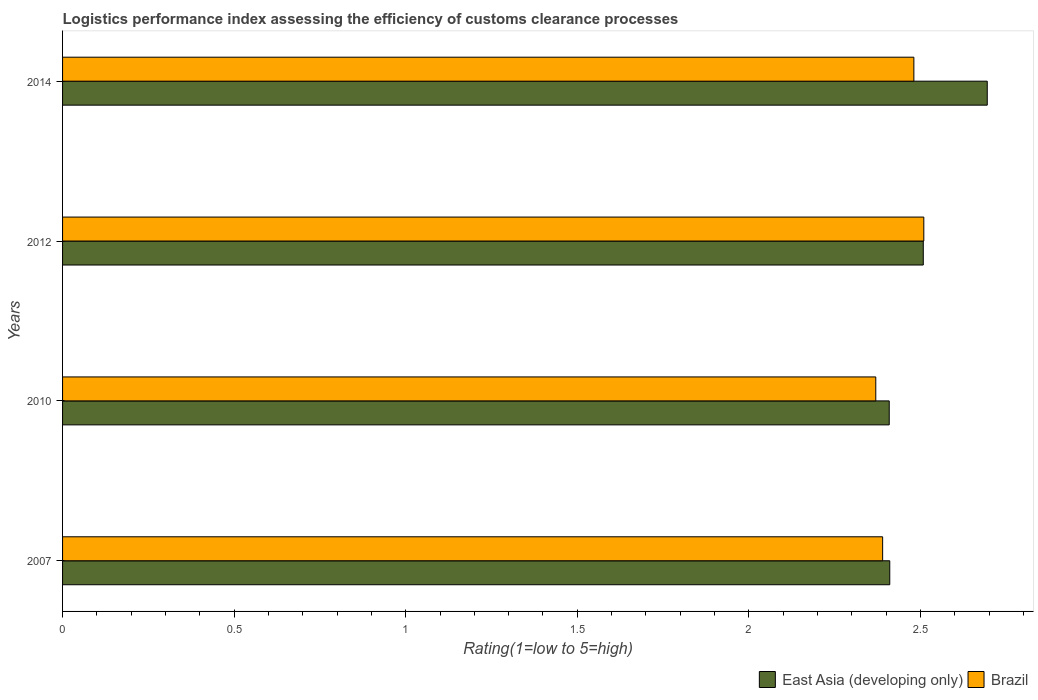How many groups of bars are there?
Give a very brief answer. 4. What is the Logistic performance index in East Asia (developing only) in 2012?
Offer a terse response. 2.51. Across all years, what is the maximum Logistic performance index in East Asia (developing only)?
Provide a succinct answer. 2.69. Across all years, what is the minimum Logistic performance index in East Asia (developing only)?
Your answer should be very brief. 2.41. In which year was the Logistic performance index in East Asia (developing only) minimum?
Offer a terse response. 2010. What is the total Logistic performance index in East Asia (developing only) in the graph?
Offer a very short reply. 10.02. What is the difference between the Logistic performance index in East Asia (developing only) in 2007 and that in 2010?
Provide a short and direct response. 0. What is the difference between the Logistic performance index in East Asia (developing only) in 2014 and the Logistic performance index in Brazil in 2012?
Make the answer very short. 0.18. What is the average Logistic performance index in East Asia (developing only) per year?
Ensure brevity in your answer.  2.51. In the year 2010, what is the difference between the Logistic performance index in East Asia (developing only) and Logistic performance index in Brazil?
Your response must be concise. 0.04. In how many years, is the Logistic performance index in East Asia (developing only) greater than 2 ?
Your response must be concise. 4. What is the ratio of the Logistic performance index in Brazil in 2007 to that in 2012?
Keep it short and to the point. 0.95. Is the Logistic performance index in Brazil in 2010 less than that in 2012?
Offer a terse response. Yes. Is the difference between the Logistic performance index in East Asia (developing only) in 2012 and 2014 greater than the difference between the Logistic performance index in Brazil in 2012 and 2014?
Make the answer very short. No. What is the difference between the highest and the second highest Logistic performance index in Brazil?
Ensure brevity in your answer.  0.03. What is the difference between the highest and the lowest Logistic performance index in East Asia (developing only)?
Give a very brief answer. 0.29. In how many years, is the Logistic performance index in East Asia (developing only) greater than the average Logistic performance index in East Asia (developing only) taken over all years?
Your answer should be compact. 2. What does the 2nd bar from the top in 2007 represents?
Your answer should be compact. East Asia (developing only). How many years are there in the graph?
Ensure brevity in your answer.  4. What is the difference between two consecutive major ticks on the X-axis?
Ensure brevity in your answer.  0.5. Does the graph contain any zero values?
Offer a very short reply. No. How many legend labels are there?
Offer a terse response. 2. How are the legend labels stacked?
Give a very brief answer. Horizontal. What is the title of the graph?
Provide a short and direct response. Logistics performance index assessing the efficiency of customs clearance processes. What is the label or title of the X-axis?
Provide a succinct answer. Rating(1=low to 5=high). What is the label or title of the Y-axis?
Your answer should be compact. Years. What is the Rating(1=low to 5=high) of East Asia (developing only) in 2007?
Your answer should be very brief. 2.41. What is the Rating(1=low to 5=high) in Brazil in 2007?
Ensure brevity in your answer.  2.39. What is the Rating(1=low to 5=high) in East Asia (developing only) in 2010?
Keep it short and to the point. 2.41. What is the Rating(1=low to 5=high) of Brazil in 2010?
Give a very brief answer. 2.37. What is the Rating(1=low to 5=high) of East Asia (developing only) in 2012?
Offer a very short reply. 2.51. What is the Rating(1=low to 5=high) in Brazil in 2012?
Make the answer very short. 2.51. What is the Rating(1=low to 5=high) in East Asia (developing only) in 2014?
Provide a succinct answer. 2.69. What is the Rating(1=low to 5=high) of Brazil in 2014?
Make the answer very short. 2.48. Across all years, what is the maximum Rating(1=low to 5=high) in East Asia (developing only)?
Ensure brevity in your answer.  2.69. Across all years, what is the maximum Rating(1=low to 5=high) in Brazil?
Your answer should be compact. 2.51. Across all years, what is the minimum Rating(1=low to 5=high) of East Asia (developing only)?
Give a very brief answer. 2.41. Across all years, what is the minimum Rating(1=low to 5=high) in Brazil?
Provide a succinct answer. 2.37. What is the total Rating(1=low to 5=high) of East Asia (developing only) in the graph?
Give a very brief answer. 10.02. What is the total Rating(1=low to 5=high) of Brazil in the graph?
Your answer should be very brief. 9.75. What is the difference between the Rating(1=low to 5=high) of East Asia (developing only) in 2007 and that in 2010?
Keep it short and to the point. 0. What is the difference between the Rating(1=low to 5=high) of East Asia (developing only) in 2007 and that in 2012?
Offer a terse response. -0.1. What is the difference between the Rating(1=low to 5=high) in Brazil in 2007 and that in 2012?
Make the answer very short. -0.12. What is the difference between the Rating(1=low to 5=high) of East Asia (developing only) in 2007 and that in 2014?
Your answer should be very brief. -0.28. What is the difference between the Rating(1=low to 5=high) of Brazil in 2007 and that in 2014?
Provide a succinct answer. -0.09. What is the difference between the Rating(1=low to 5=high) in East Asia (developing only) in 2010 and that in 2012?
Provide a short and direct response. -0.1. What is the difference between the Rating(1=low to 5=high) in Brazil in 2010 and that in 2012?
Your answer should be compact. -0.14. What is the difference between the Rating(1=low to 5=high) in East Asia (developing only) in 2010 and that in 2014?
Your response must be concise. -0.29. What is the difference between the Rating(1=low to 5=high) in Brazil in 2010 and that in 2014?
Ensure brevity in your answer.  -0.11. What is the difference between the Rating(1=low to 5=high) of East Asia (developing only) in 2012 and that in 2014?
Keep it short and to the point. -0.19. What is the difference between the Rating(1=low to 5=high) in Brazil in 2012 and that in 2014?
Make the answer very short. 0.03. What is the difference between the Rating(1=low to 5=high) in East Asia (developing only) in 2007 and the Rating(1=low to 5=high) in Brazil in 2010?
Keep it short and to the point. 0.04. What is the difference between the Rating(1=low to 5=high) in East Asia (developing only) in 2007 and the Rating(1=low to 5=high) in Brazil in 2012?
Offer a terse response. -0.1. What is the difference between the Rating(1=low to 5=high) in East Asia (developing only) in 2007 and the Rating(1=low to 5=high) in Brazil in 2014?
Provide a short and direct response. -0.07. What is the difference between the Rating(1=low to 5=high) in East Asia (developing only) in 2010 and the Rating(1=low to 5=high) in Brazil in 2012?
Offer a very short reply. -0.1. What is the difference between the Rating(1=low to 5=high) of East Asia (developing only) in 2010 and the Rating(1=low to 5=high) of Brazil in 2014?
Make the answer very short. -0.07. What is the difference between the Rating(1=low to 5=high) of East Asia (developing only) in 2012 and the Rating(1=low to 5=high) of Brazil in 2014?
Make the answer very short. 0.03. What is the average Rating(1=low to 5=high) in East Asia (developing only) per year?
Ensure brevity in your answer.  2.51. What is the average Rating(1=low to 5=high) in Brazil per year?
Provide a short and direct response. 2.44. In the year 2007, what is the difference between the Rating(1=low to 5=high) of East Asia (developing only) and Rating(1=low to 5=high) of Brazil?
Make the answer very short. 0.02. In the year 2010, what is the difference between the Rating(1=low to 5=high) in East Asia (developing only) and Rating(1=low to 5=high) in Brazil?
Offer a very short reply. 0.04. In the year 2012, what is the difference between the Rating(1=low to 5=high) in East Asia (developing only) and Rating(1=low to 5=high) in Brazil?
Offer a terse response. -0. In the year 2014, what is the difference between the Rating(1=low to 5=high) in East Asia (developing only) and Rating(1=low to 5=high) in Brazil?
Your answer should be very brief. 0.21. What is the ratio of the Rating(1=low to 5=high) in East Asia (developing only) in 2007 to that in 2010?
Provide a succinct answer. 1. What is the ratio of the Rating(1=low to 5=high) in Brazil in 2007 to that in 2010?
Your response must be concise. 1.01. What is the ratio of the Rating(1=low to 5=high) in East Asia (developing only) in 2007 to that in 2012?
Offer a very short reply. 0.96. What is the ratio of the Rating(1=low to 5=high) in Brazil in 2007 to that in 2012?
Give a very brief answer. 0.95. What is the ratio of the Rating(1=low to 5=high) in East Asia (developing only) in 2007 to that in 2014?
Provide a short and direct response. 0.89. What is the ratio of the Rating(1=low to 5=high) in Brazil in 2007 to that in 2014?
Ensure brevity in your answer.  0.96. What is the ratio of the Rating(1=low to 5=high) in East Asia (developing only) in 2010 to that in 2012?
Your response must be concise. 0.96. What is the ratio of the Rating(1=low to 5=high) in Brazil in 2010 to that in 2012?
Keep it short and to the point. 0.94. What is the ratio of the Rating(1=low to 5=high) in East Asia (developing only) in 2010 to that in 2014?
Your response must be concise. 0.89. What is the ratio of the Rating(1=low to 5=high) in Brazil in 2010 to that in 2014?
Your answer should be very brief. 0.96. What is the ratio of the Rating(1=low to 5=high) of East Asia (developing only) in 2012 to that in 2014?
Provide a short and direct response. 0.93. What is the ratio of the Rating(1=low to 5=high) of Brazil in 2012 to that in 2014?
Make the answer very short. 1.01. What is the difference between the highest and the second highest Rating(1=low to 5=high) of East Asia (developing only)?
Your response must be concise. 0.19. What is the difference between the highest and the second highest Rating(1=low to 5=high) of Brazil?
Offer a very short reply. 0.03. What is the difference between the highest and the lowest Rating(1=low to 5=high) of East Asia (developing only)?
Give a very brief answer. 0.29. What is the difference between the highest and the lowest Rating(1=low to 5=high) of Brazil?
Give a very brief answer. 0.14. 